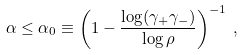Convert formula to latex. <formula><loc_0><loc_0><loc_500><loc_500>\alpha \leq \alpha _ { 0 } \equiv \left ( 1 - \frac { \log ( \gamma _ { + } \gamma _ { - } ) } { \log { \rho } } \right ) ^ { - 1 } \, ,</formula> 